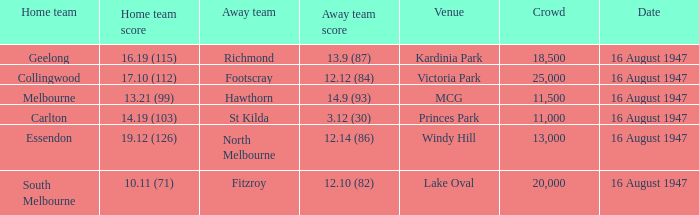What was the total size of the crowd when the away team scored 12.10 (82)? 20000.0. 